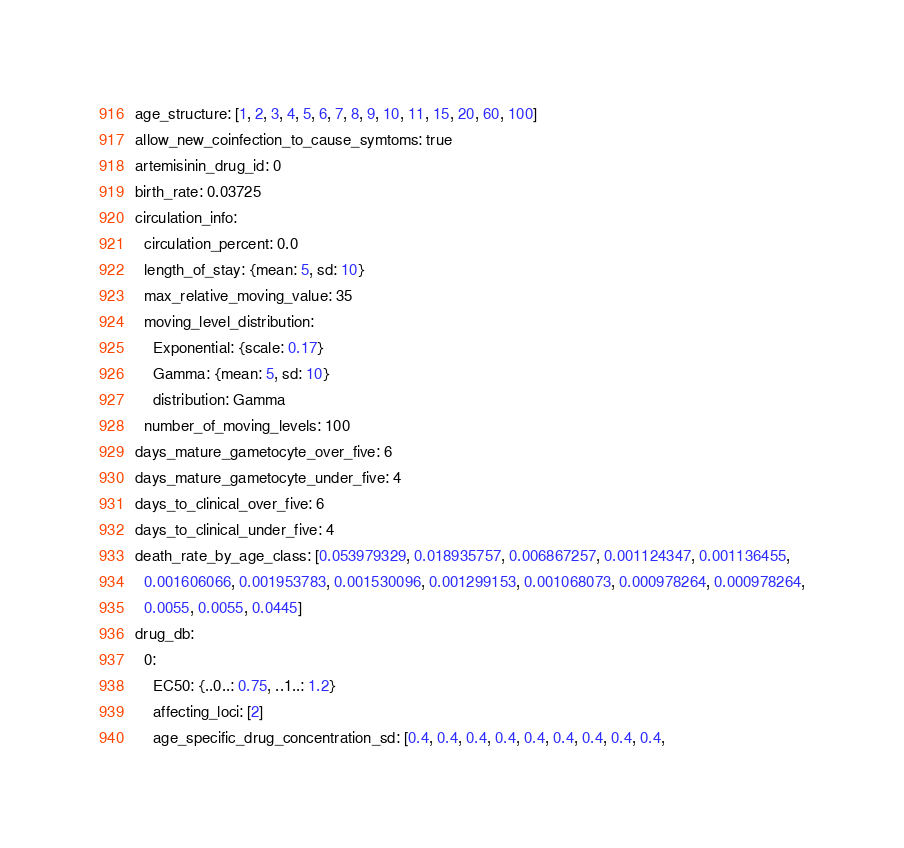Convert code to text. <code><loc_0><loc_0><loc_500><loc_500><_YAML_>age_structure: [1, 2, 3, 4, 5, 6, 7, 8, 9, 10, 11, 15, 20, 60, 100]
allow_new_coinfection_to_cause_symtoms: true
artemisinin_drug_id: 0
birth_rate: 0.03725
circulation_info:
  circulation_percent: 0.0
  length_of_stay: {mean: 5, sd: 10}
  max_relative_moving_value: 35
  moving_level_distribution:
    Exponential: {scale: 0.17}
    Gamma: {mean: 5, sd: 10}
    distribution: Gamma
  number_of_moving_levels: 100
days_mature_gametocyte_over_five: 6
days_mature_gametocyte_under_five: 4
days_to_clinical_over_five: 6
days_to_clinical_under_five: 4
death_rate_by_age_class: [0.053979329, 0.018935757, 0.006867257, 0.001124347, 0.001136455,
  0.001606066, 0.001953783, 0.001530096, 0.001299153, 0.001068073, 0.000978264, 0.000978264,
  0.0055, 0.0055, 0.0445]
drug_db:
  0:
    EC50: {..0..: 0.75, ..1..: 1.2}
    affecting_loci: [2]
    age_specific_drug_concentration_sd: [0.4, 0.4, 0.4, 0.4, 0.4, 0.4, 0.4, 0.4, 0.4,</code> 